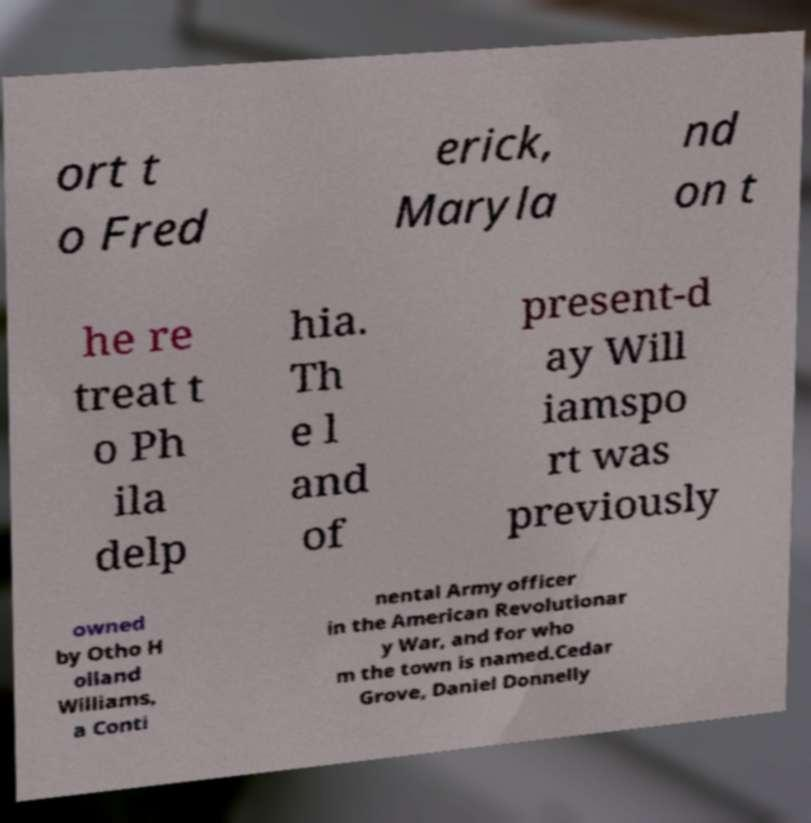There's text embedded in this image that I need extracted. Can you transcribe it verbatim? ort t o Fred erick, Maryla nd on t he re treat t o Ph ila delp hia. Th e l and of present-d ay Will iamspo rt was previously owned by Otho H olland Williams, a Conti nental Army officer in the American Revolutionar y War, and for who m the town is named.Cedar Grove, Daniel Donnelly 